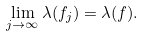<formula> <loc_0><loc_0><loc_500><loc_500>\lim _ { j \to \infty } \lambda ( f _ { j } ) = \lambda ( f ) .</formula> 